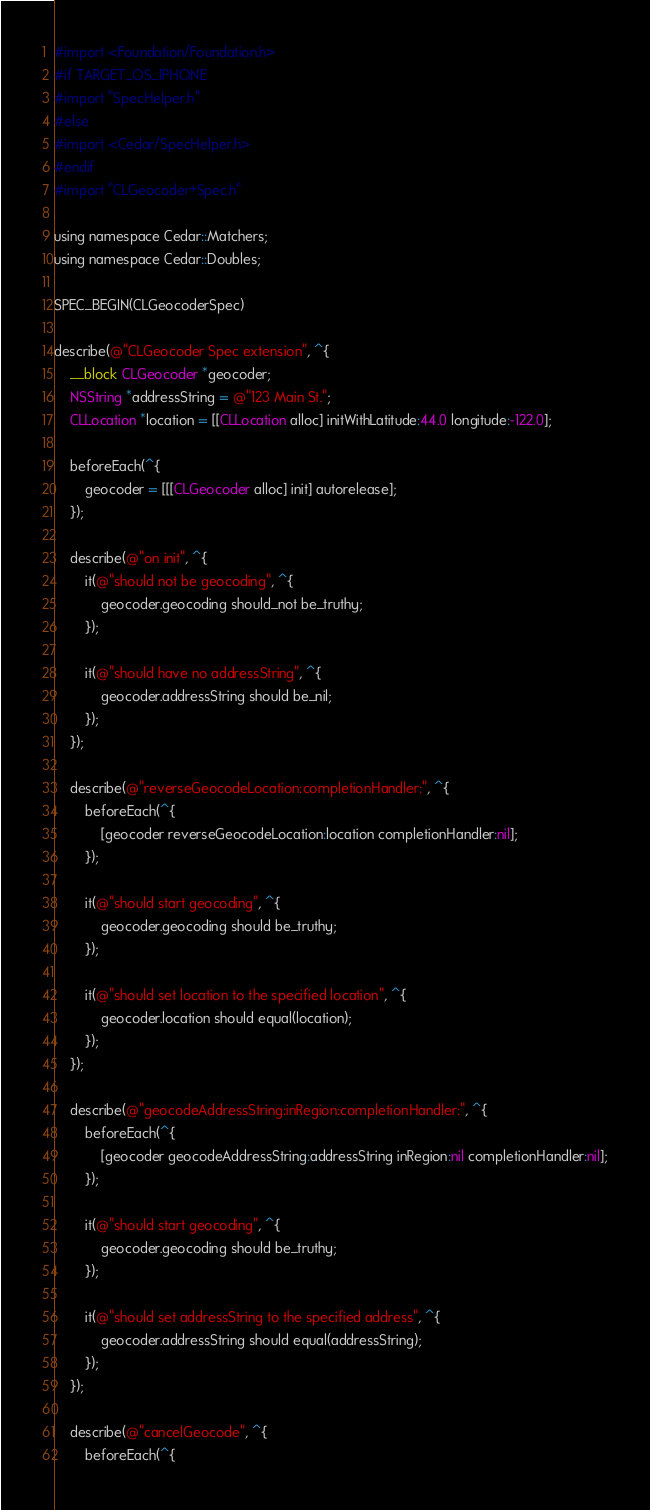Convert code to text. <code><loc_0><loc_0><loc_500><loc_500><_ObjectiveC_>#import <Foundation/Foundation.h>
#if TARGET_OS_IPHONE
#import "SpecHelper.h"
#else
#import <Cedar/SpecHelper.h>
#endif
#import "CLGeocoder+Spec.h"

using namespace Cedar::Matchers;
using namespace Cedar::Doubles;

SPEC_BEGIN(CLGeocoderSpec)

describe(@"CLGeocoder Spec extension", ^{
    __block CLGeocoder *geocoder;
    NSString *addressString = @"123 Main St.";
    CLLocation *location = [[CLLocation alloc] initWithLatitude:44.0 longitude:-122.0];

    beforeEach(^{
        geocoder = [[[CLGeocoder alloc] init] autorelease];
    });

    describe(@"on init", ^{
        it(@"should not be geocoding", ^{
            geocoder.geocoding should_not be_truthy;
        });

        it(@"should have no addressString", ^{
            geocoder.addressString should be_nil;
        });
    });

    describe(@"reverseGeocodeLocation:completionHandler:", ^{
        beforeEach(^{
            [geocoder reverseGeocodeLocation:location completionHandler:nil];
        });

        it(@"should start geocoding", ^{
            geocoder.geocoding should be_truthy;
        });

        it(@"should set location to the specified location", ^{
            geocoder.location should equal(location);
        });
    });

    describe(@"geocodeAddressString:inRegion:completionHandler:", ^{
        beforeEach(^{
            [geocoder geocodeAddressString:addressString inRegion:nil completionHandler:nil];
        });

        it(@"should start geocoding", ^{
            geocoder.geocoding should be_truthy;
        });

        it(@"should set addressString to the specified address", ^{
            geocoder.addressString should equal(addressString);
        });
    });

    describe(@"cancelGeocode", ^{
        beforeEach(^{</code> 